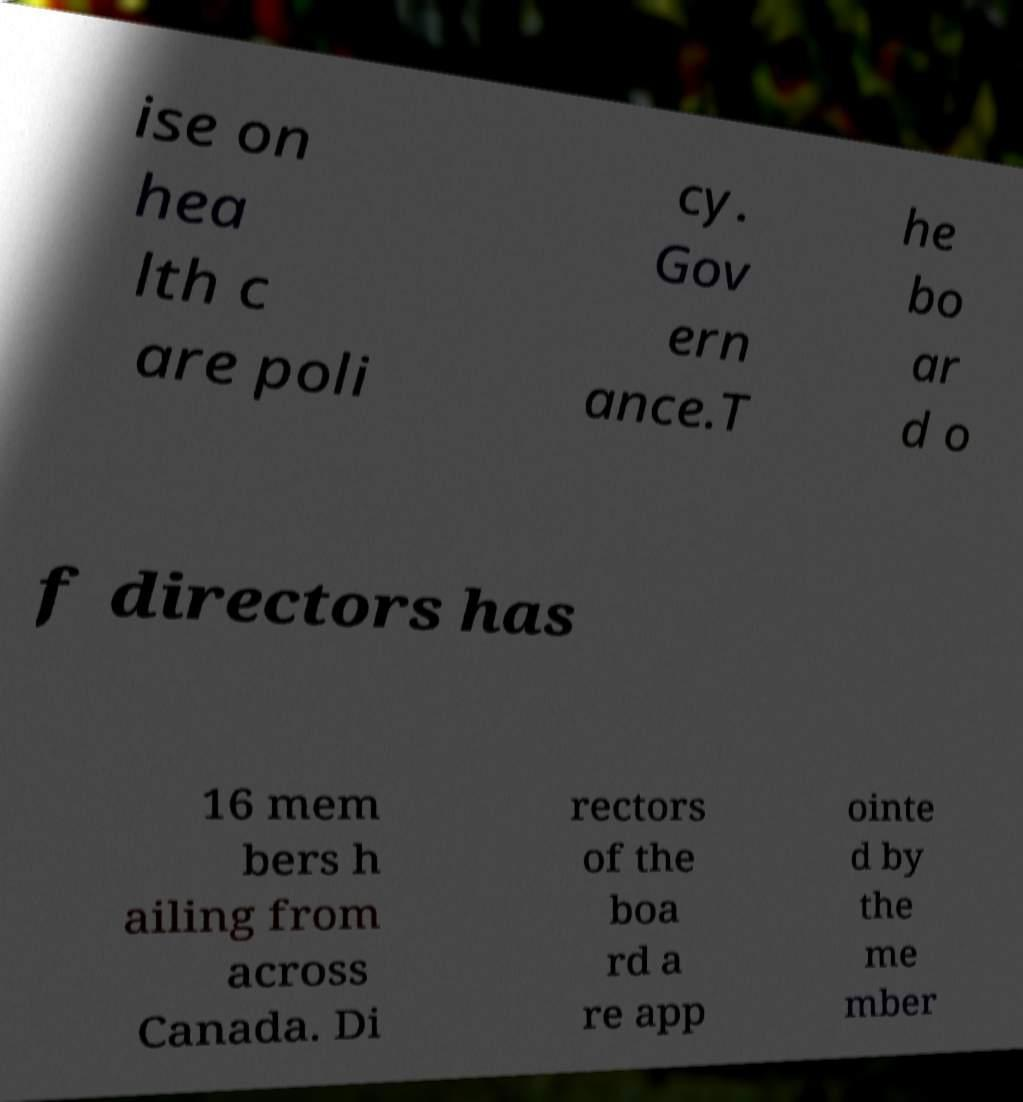Can you read and provide the text displayed in the image?This photo seems to have some interesting text. Can you extract and type it out for me? ise on hea lth c are poli cy. Gov ern ance.T he bo ar d o f directors has 16 mem bers h ailing from across Canada. Di rectors of the boa rd a re app ointe d by the me mber 